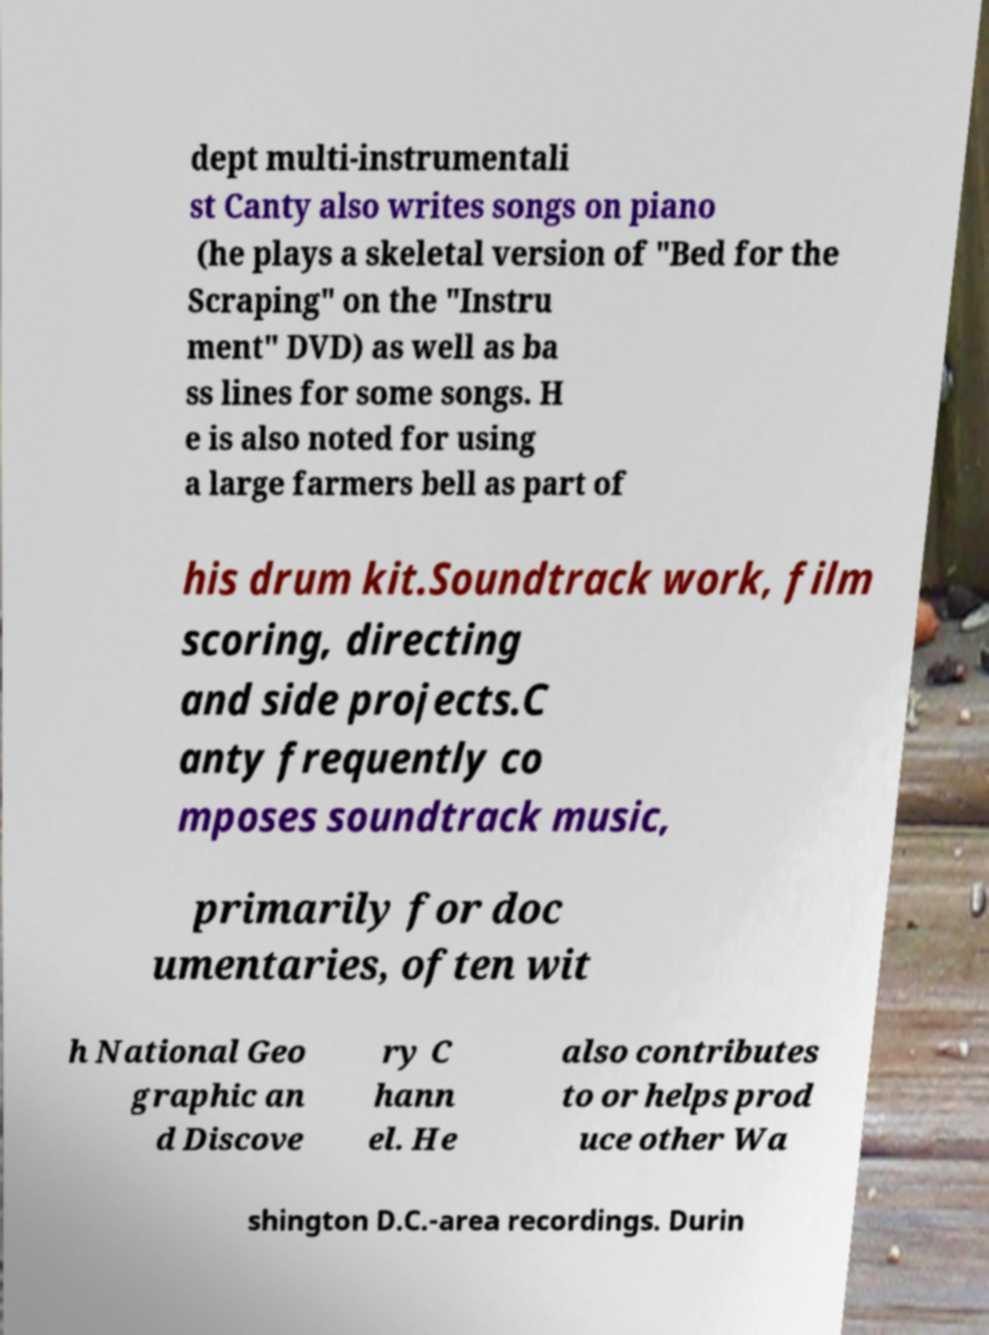Please read and relay the text visible in this image. What does it say? dept multi-instrumentali st Canty also writes songs on piano (he plays a skeletal version of "Bed for the Scraping" on the "Instru ment" DVD) as well as ba ss lines for some songs. H e is also noted for using a large farmers bell as part of his drum kit.Soundtrack work, film scoring, directing and side projects.C anty frequently co mposes soundtrack music, primarily for doc umentaries, often wit h National Geo graphic an d Discove ry C hann el. He also contributes to or helps prod uce other Wa shington D.C.-area recordings. Durin 